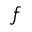<formula> <loc_0><loc_0><loc_500><loc_500>f</formula> 